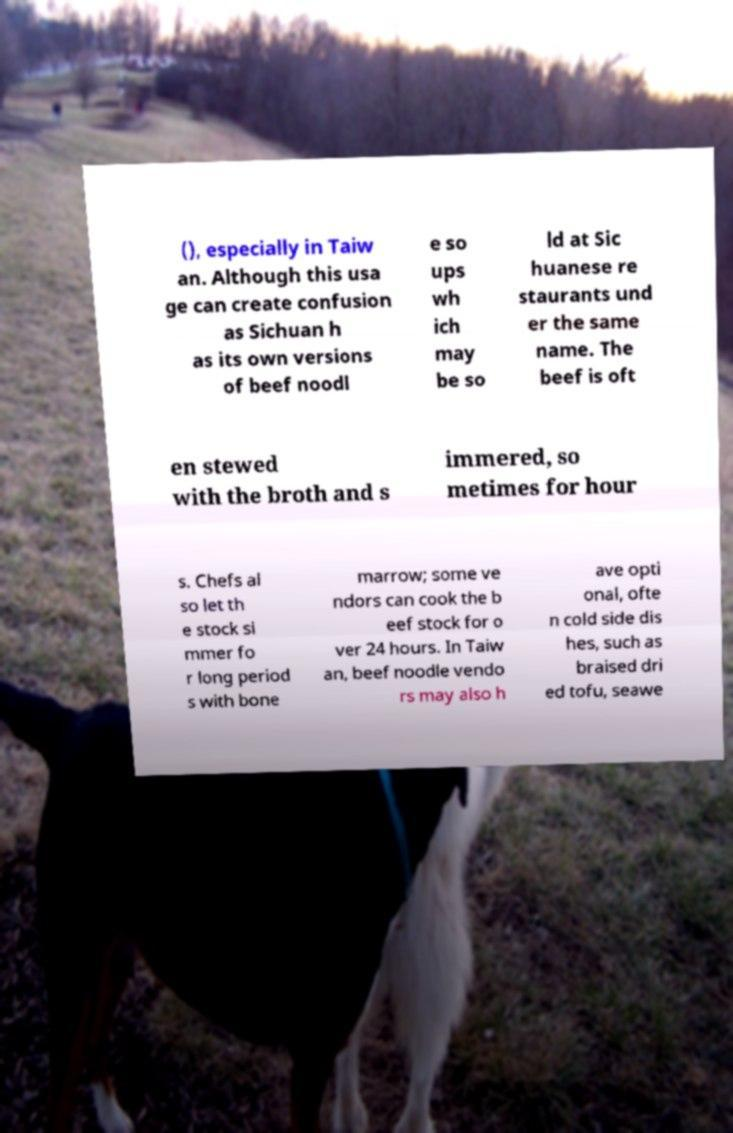What messages or text are displayed in this image? I need them in a readable, typed format. (), especially in Taiw an. Although this usa ge can create confusion as Sichuan h as its own versions of beef noodl e so ups wh ich may be so ld at Sic huanese re staurants und er the same name. The beef is oft en stewed with the broth and s immered, so metimes for hour s. Chefs al so let th e stock si mmer fo r long period s with bone marrow; some ve ndors can cook the b eef stock for o ver 24 hours. In Taiw an, beef noodle vendo rs may also h ave opti onal, ofte n cold side dis hes, such as braised dri ed tofu, seawe 